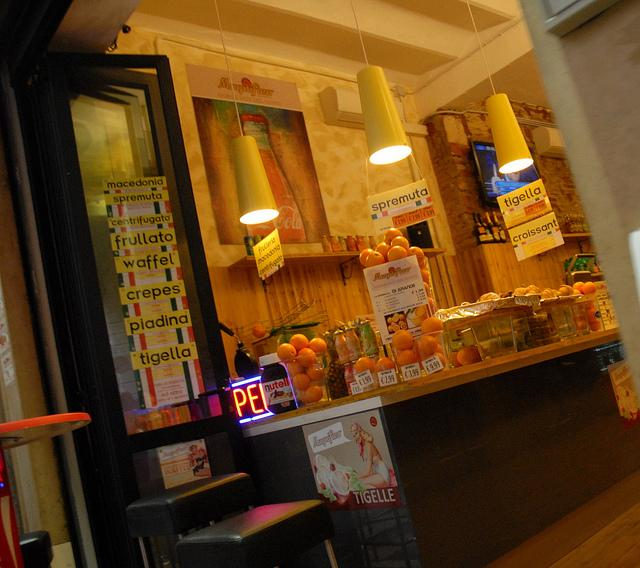What do people do here? buy food 